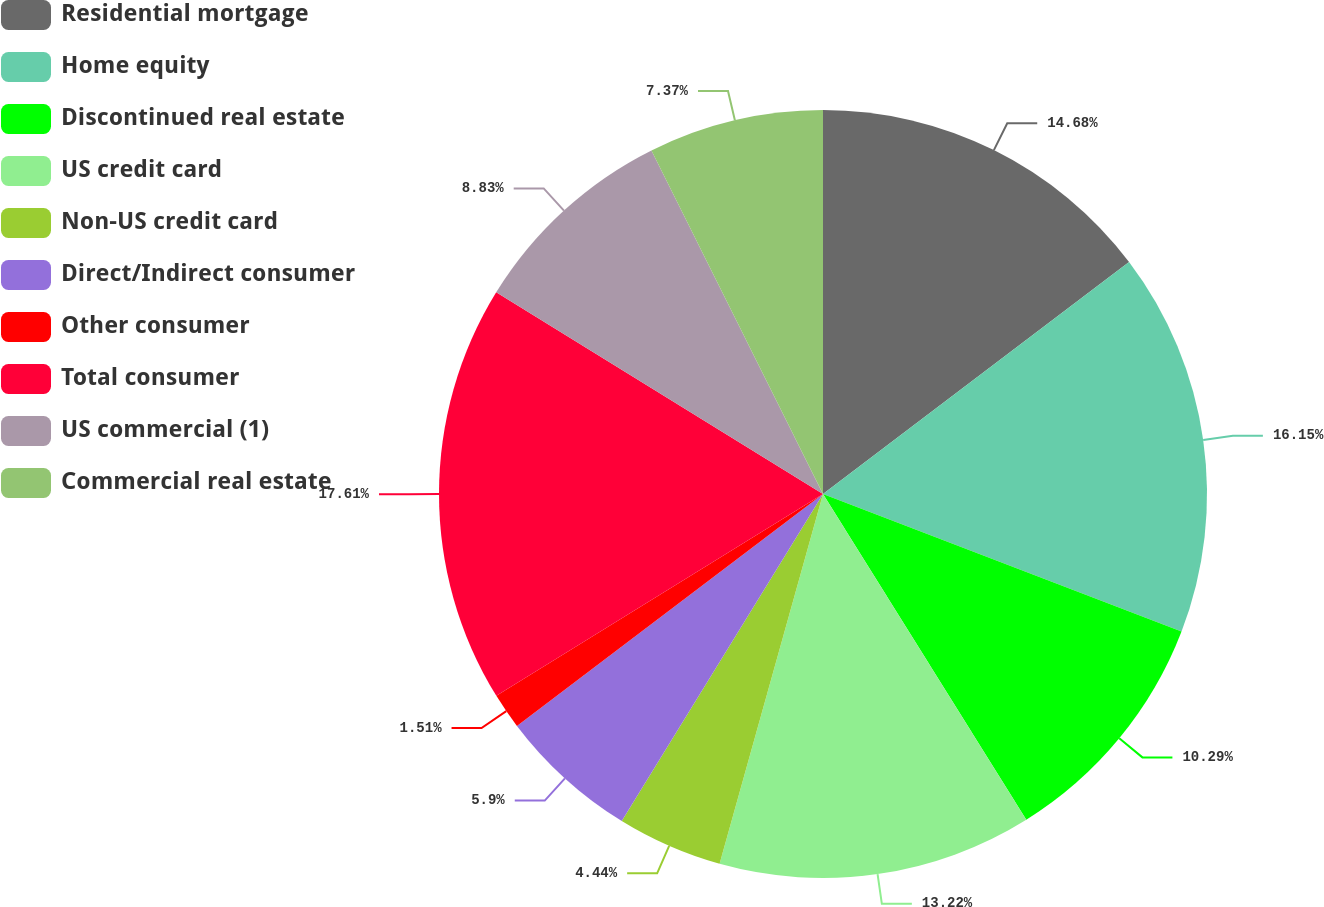Convert chart to OTSL. <chart><loc_0><loc_0><loc_500><loc_500><pie_chart><fcel>Residential mortgage<fcel>Home equity<fcel>Discontinued real estate<fcel>US credit card<fcel>Non-US credit card<fcel>Direct/Indirect consumer<fcel>Other consumer<fcel>Total consumer<fcel>US commercial (1)<fcel>Commercial real estate<nl><fcel>14.68%<fcel>16.15%<fcel>10.29%<fcel>13.22%<fcel>4.44%<fcel>5.9%<fcel>1.51%<fcel>17.61%<fcel>8.83%<fcel>7.37%<nl></chart> 